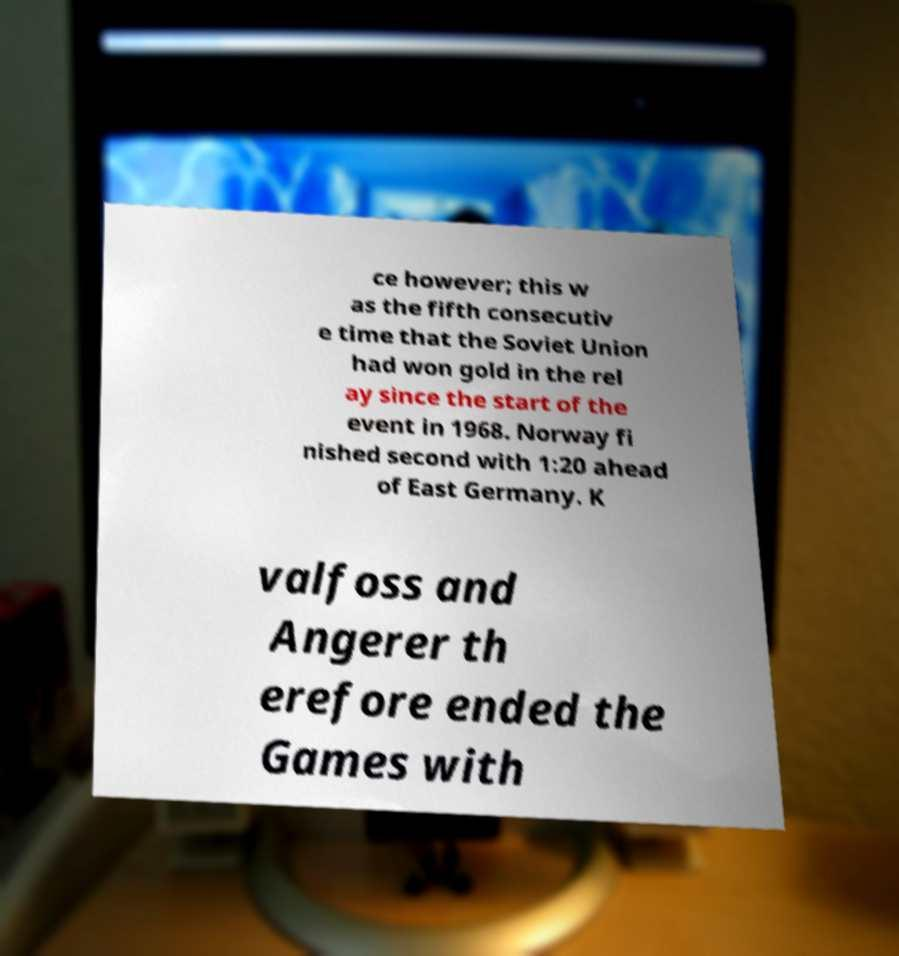There's text embedded in this image that I need extracted. Can you transcribe it verbatim? ce however; this w as the fifth consecutiv e time that the Soviet Union had won gold in the rel ay since the start of the event in 1968. Norway fi nished second with 1:20 ahead of East Germany. K valfoss and Angerer th erefore ended the Games with 